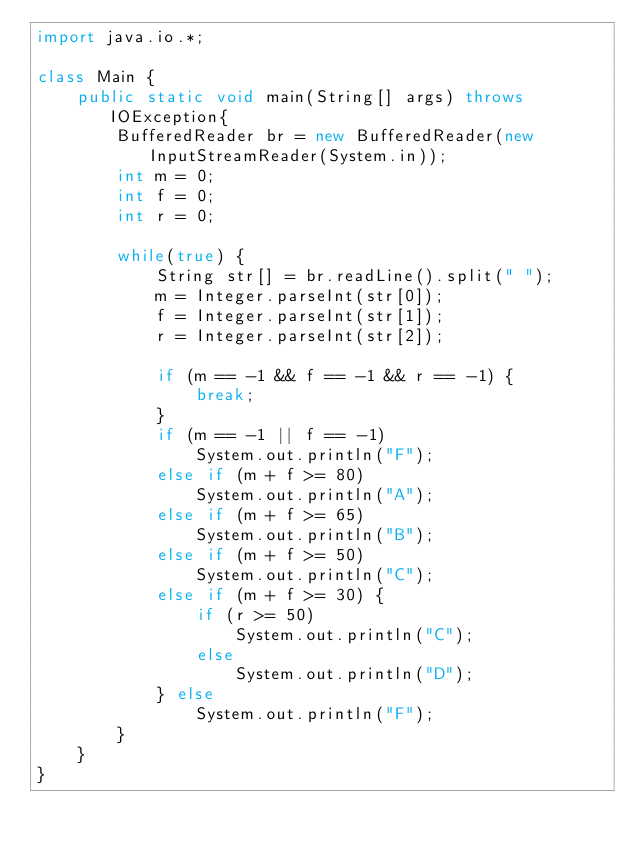Convert code to text. <code><loc_0><loc_0><loc_500><loc_500><_Java_>import java.io.*;

class Main {
    public static void main(String[] args) throws IOException{
        BufferedReader br = new BufferedReader(new InputStreamReader(System.in));
        int m = 0;
        int f = 0;
        int r = 0;        
        
        while(true) {
            String str[] = br.readLine().split(" ");
            m = Integer.parseInt(str[0]);
            f = Integer.parseInt(str[1]);
            r = Integer.parseInt(str[2]);

            if (m == -1 && f == -1 && r == -1) {
                break;
            }
            if (m == -1 || f == -1)
                System.out.println("F");
            else if (m + f >= 80)
                System.out.println("A");
            else if (m + f >= 65)
                System.out.println("B");
            else if (m + f >= 50)
                System.out.println("C");
            else if (m + f >= 30) {
                if (r >= 50)
                    System.out.println("C");
                else
                    System.out.println("D");
            } else
                System.out.println("F");
        }
    }
}</code> 